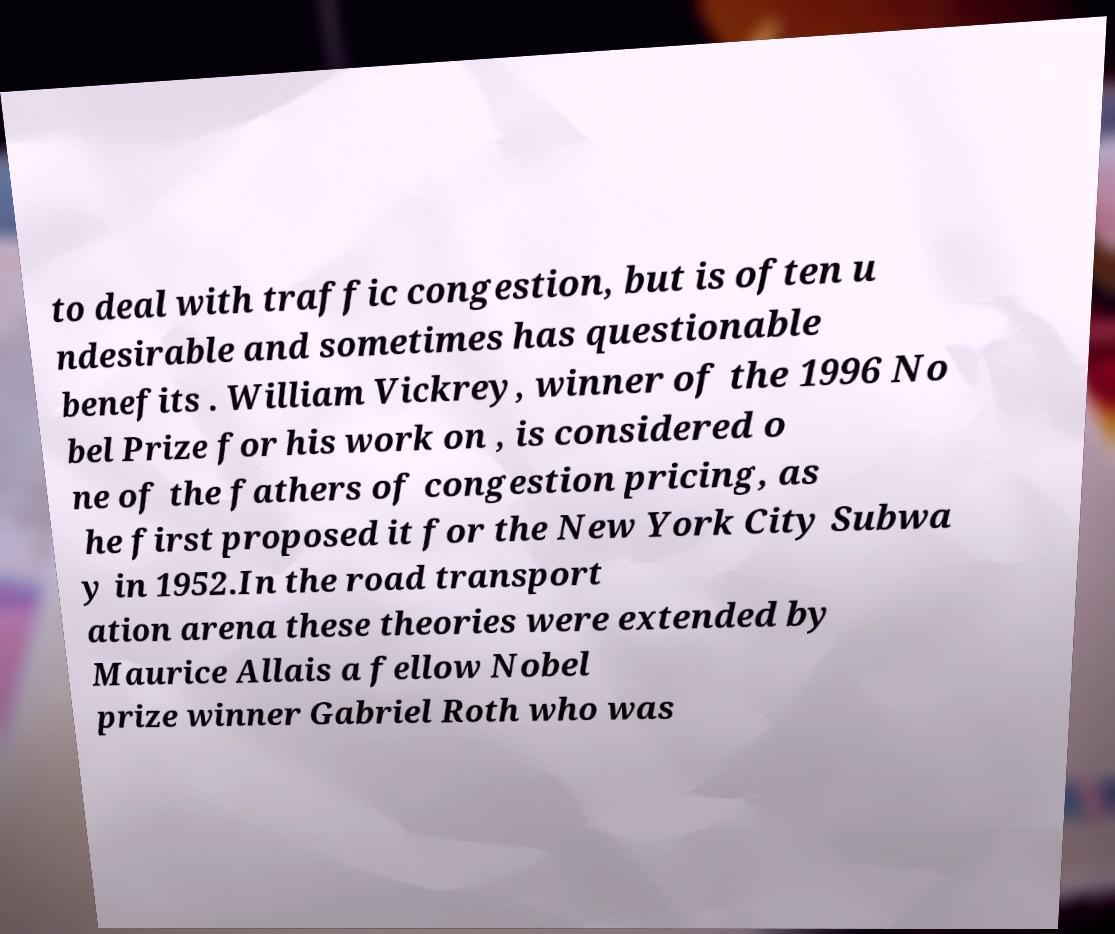Could you assist in decoding the text presented in this image and type it out clearly? to deal with traffic congestion, but is often u ndesirable and sometimes has questionable benefits . William Vickrey, winner of the 1996 No bel Prize for his work on , is considered o ne of the fathers of congestion pricing, as he first proposed it for the New York City Subwa y in 1952.In the road transport ation arena these theories were extended by Maurice Allais a fellow Nobel prize winner Gabriel Roth who was 